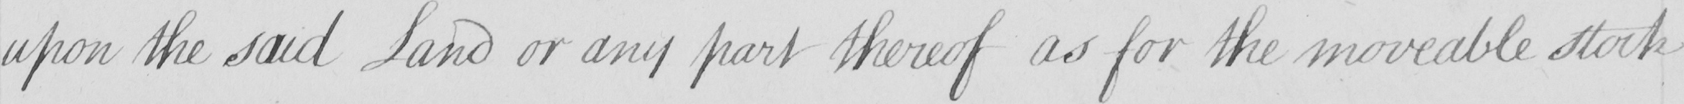Transcribe the text shown in this historical manuscript line. upon the said Land or any part thereof as for the moveable stock 